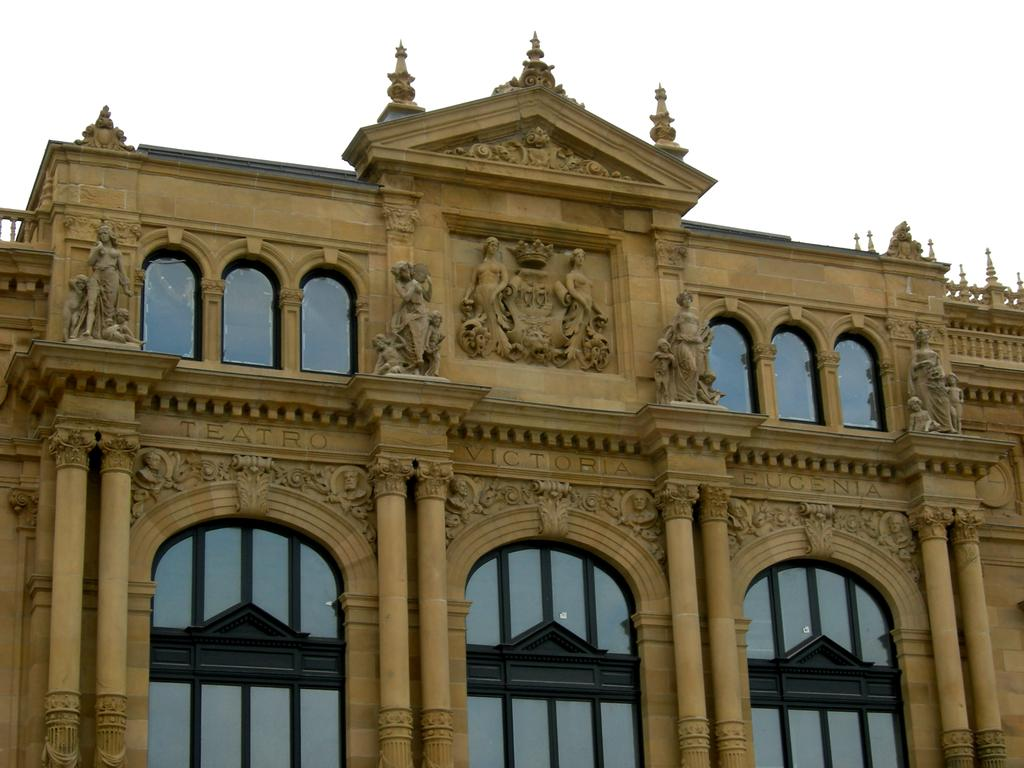What type of structure is present in the image? There is a building in the image. What is the color of the building? The building is brown in color. Are there any other objects or features near the building? Yes, there are statues near the building. What color is the background of the image? The background of the image is white. What type of addition problem is being solved on the stage in the image? There is no stage or addition problem present in the image. What type of stew is being prepared in the image? There is no stew or cooking activity present in the image. 